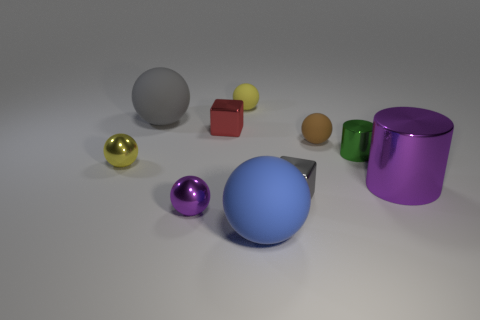Subtract all metallic balls. How many balls are left? 4 Subtract all blue blocks. How many yellow balls are left? 2 Subtract 1 balls. How many balls are left? 5 Subtract all purple balls. How many balls are left? 5 Add 3 purple shiny balls. How many purple shiny balls exist? 4 Subtract 0 red balls. How many objects are left? 10 Subtract all cylinders. How many objects are left? 8 Subtract all blue blocks. Subtract all yellow cylinders. How many blocks are left? 2 Subtract all tiny red metallic cubes. Subtract all tiny gray objects. How many objects are left? 8 Add 1 purple spheres. How many purple spheres are left? 2 